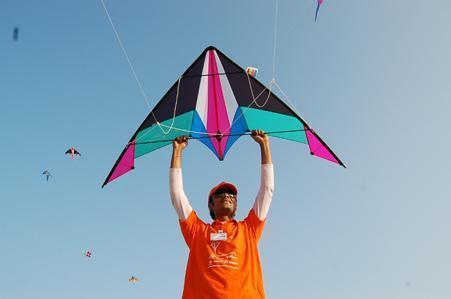How many kites are visible?
Give a very brief answer. 7. 